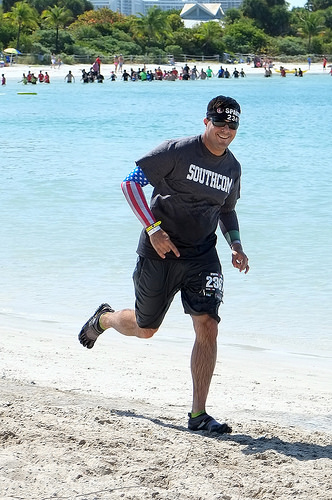<image>
Is the man behind the water? No. The man is not behind the water. From this viewpoint, the man appears to be positioned elsewhere in the scene. Where is the man in relation to the water? Is it in the water? No. The man is not contained within the water. These objects have a different spatial relationship. 